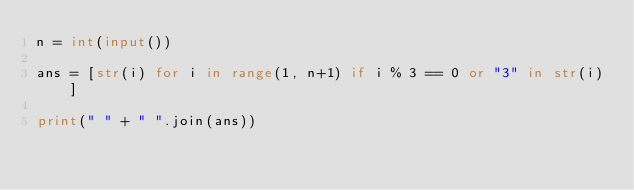<code> <loc_0><loc_0><loc_500><loc_500><_Python_>n = int(input())

ans = [str(i) for i in range(1, n+1) if i % 3 == 0 or "3" in str(i)]

print(" " + " ".join(ans))
</code> 